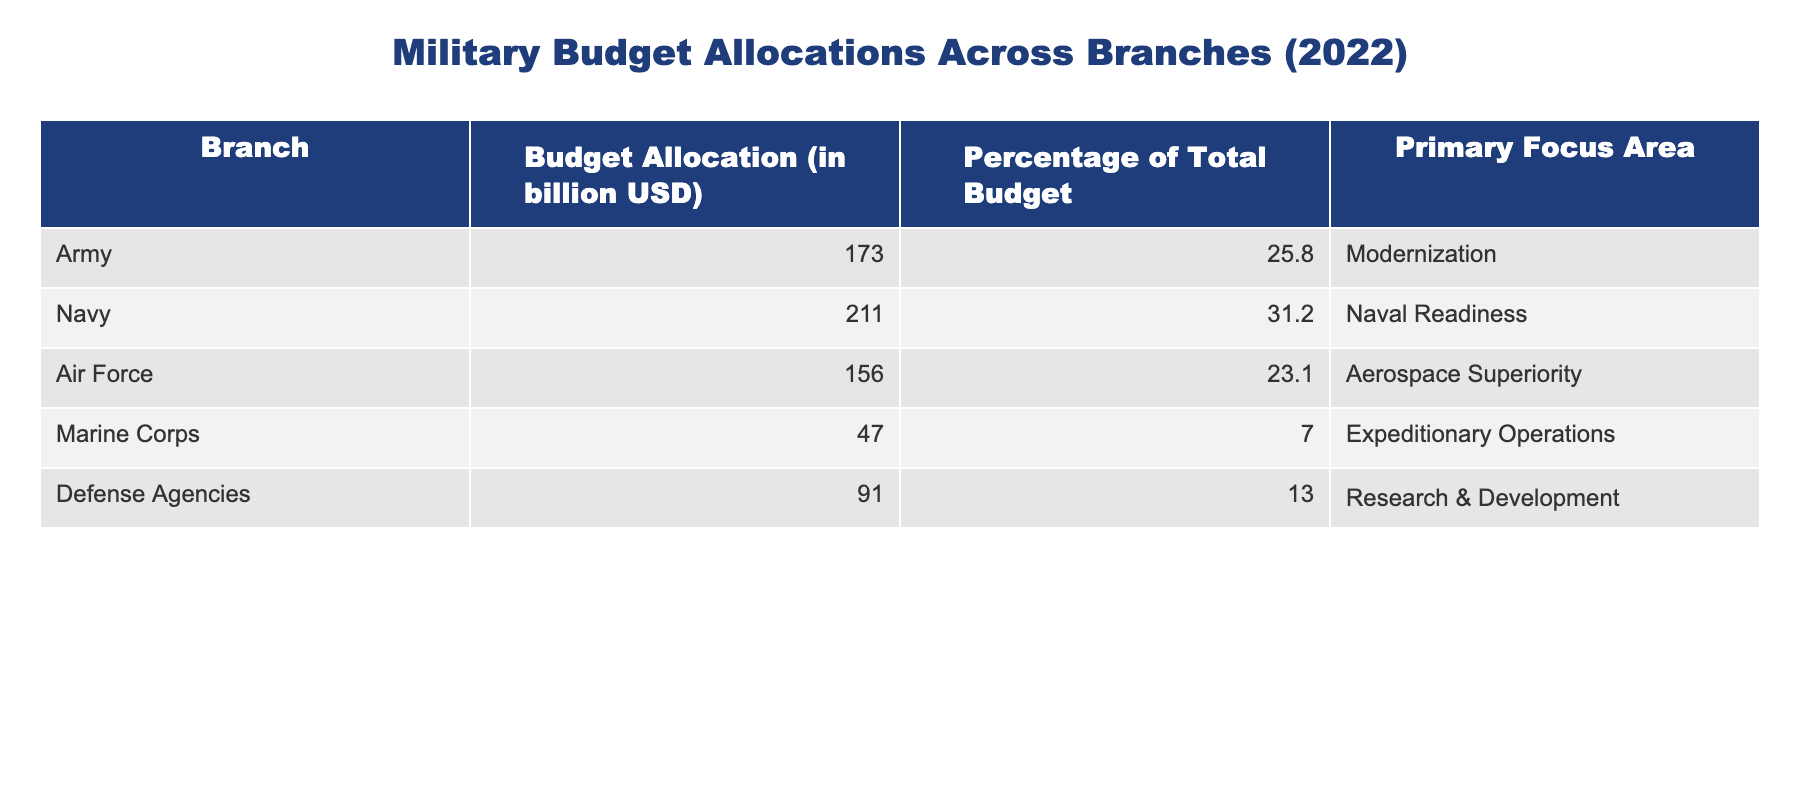What is the budget allocation for the Navy? The budget allocation for each branch is directly listed in the table. For the Navy, it states 211 billion USD.
Answer: 211 billion USD Which branch has the highest percentage of the total budget? The table shows the percentage of the total budget for each branch. The Navy's percentage is 31.2%, which is the highest compared to others.
Answer: Navy What is the total budget allocation across all branches? To find the total budget allocation, we need to sum the allocations of all branches: 173 + 211 + 156 + 47 + 91 = 678 billion USD.
Answer: 678 billion USD What percentage of the total budget does the Army receive? The table directly states that the Army's budget allocation is 25.8% of the total budget.
Answer: 25.8% Which branch has the primary focus area of Research & Development? By examining the "Primary Focus Area" column, Defense Agencies is associated with Research & Development.
Answer: Defense Agencies If the Marine Corps budget were doubled, what would its new allocation be? The Marine Corps has a budget of 47 billion USD. Doubling this would result in 47 * 2 = 94 billion USD.
Answer: 94 billion USD What is the combined budget allocation of the Army and Air Force? The Army's budget is 173 billion USD and the Air Force's budget is 156 billion USD. Adding these gives: 173 + 156 = 329 billion USD.
Answer: 329 billion USD Is the majority of the budget allocated to modernization? The Army is focused on modernization with a budget of 173 billion USD, which is less than the combined total of the Navy and other branches, hence the majority is not allocated to this focus.
Answer: No What branch has the least budget allocation? The table indicates that the Marine Corps has a budget allocation of 47 billion USD, which is the lowest among all branches listed.
Answer: Marine Corps What is the average budget allocation across all branches? To find the average, we sum all budget allocations to get 678 billion USD and divide this by the number of branches (5): 678 / 5 = 135.6 billion USD.
Answer: 135.6 billion USD 